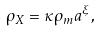<formula> <loc_0><loc_0><loc_500><loc_500>\rho _ { X } = \kappa \rho _ { m } a ^ { \xi } ,</formula> 